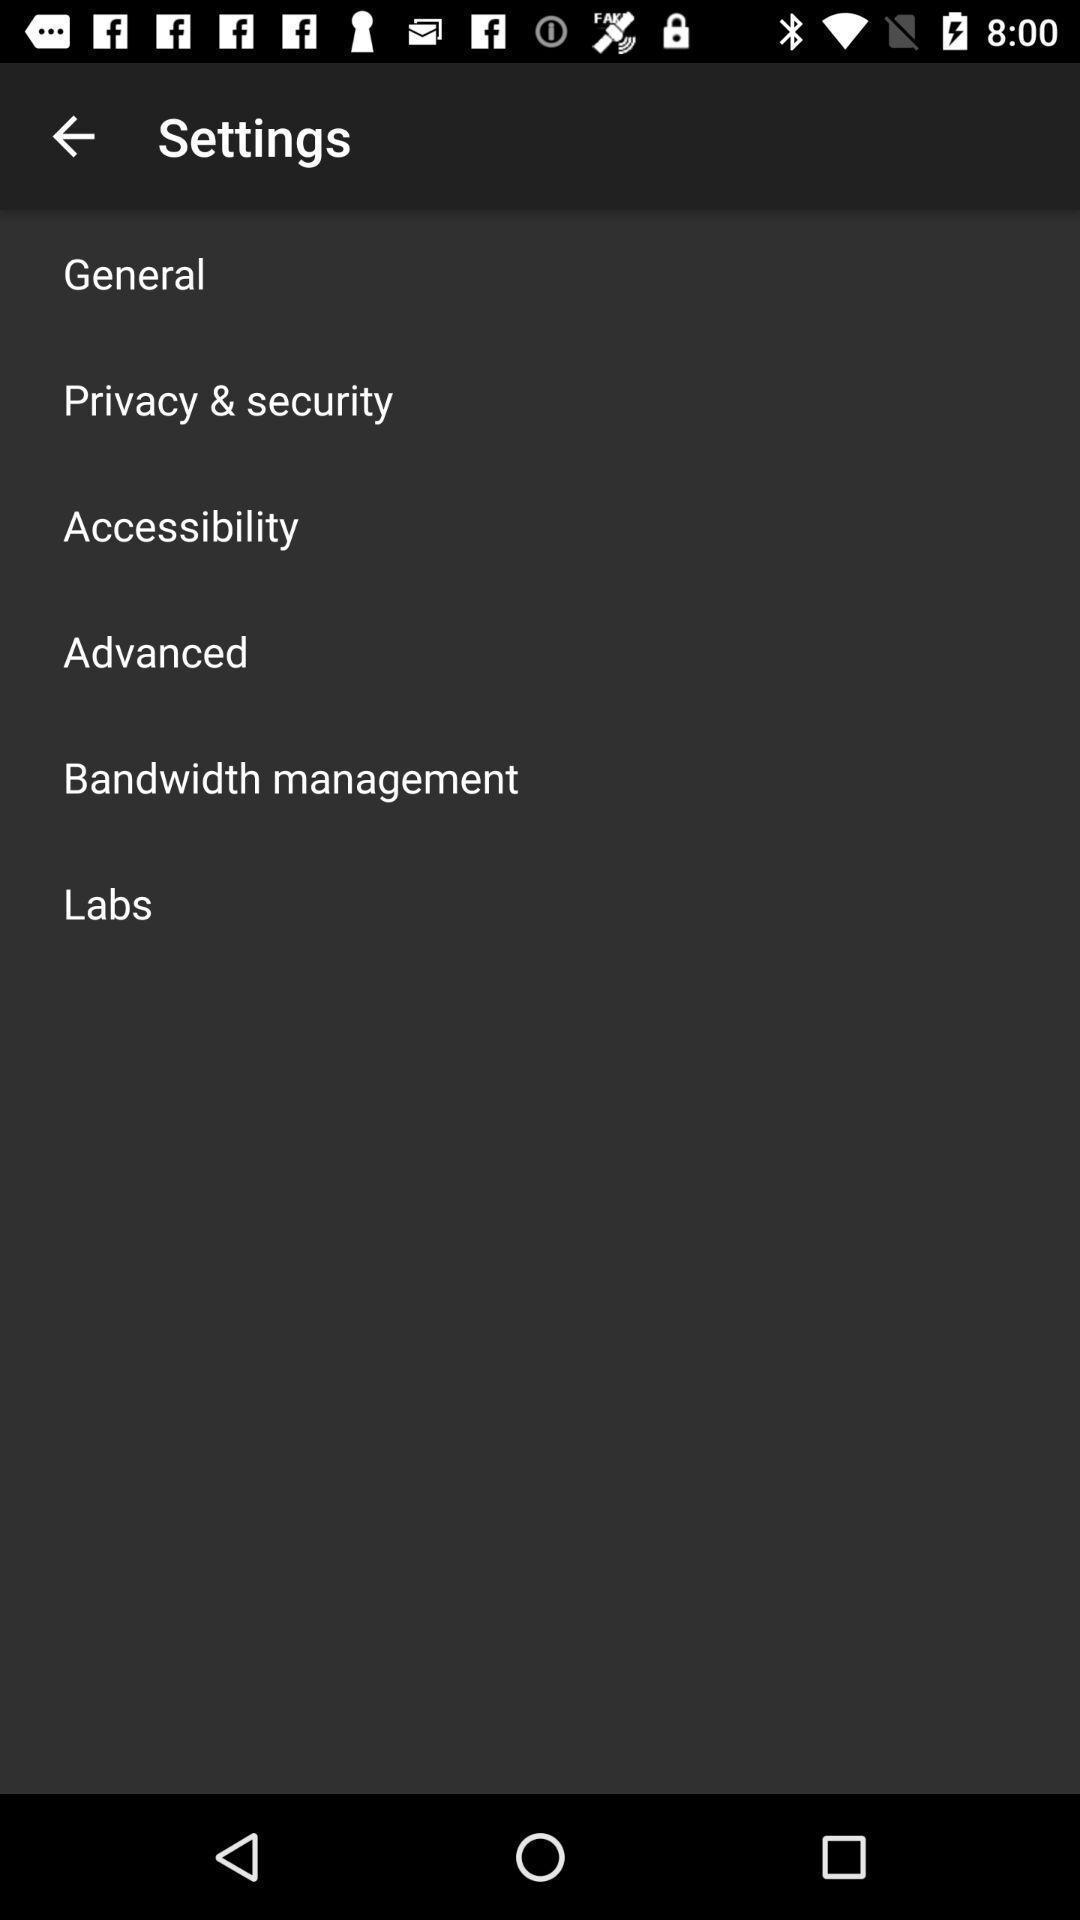Describe the visual elements of this screenshot. Page displays list of settings in app. 